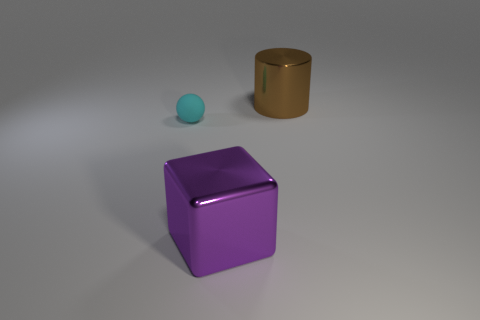Add 1 small gray metallic cylinders. How many objects exist? 4 Subtract all balls. How many objects are left? 2 Add 1 small objects. How many small objects are left? 2 Add 1 small red shiny cylinders. How many small red shiny cylinders exist? 1 Subtract 0 yellow cylinders. How many objects are left? 3 Subtract all tiny cyan balls. Subtract all large brown things. How many objects are left? 1 